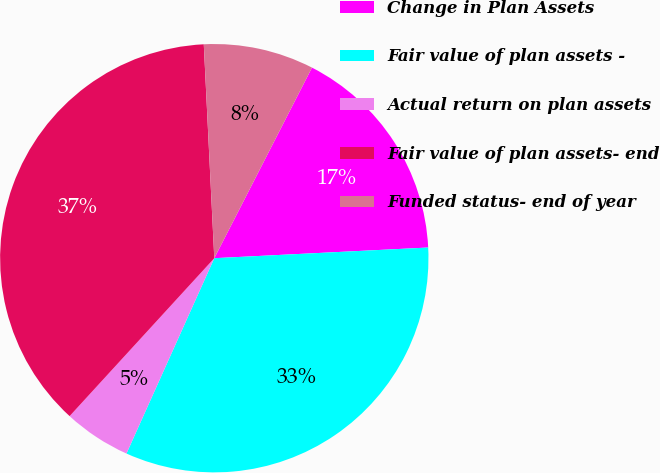Convert chart to OTSL. <chart><loc_0><loc_0><loc_500><loc_500><pie_chart><fcel>Change in Plan Assets<fcel>Fair value of plan assets -<fcel>Actual return on plan assets<fcel>Fair value of plan assets- end<fcel>Funded status- end of year<nl><fcel>16.67%<fcel>32.52%<fcel>5.08%<fcel>37.42%<fcel>8.32%<nl></chart> 